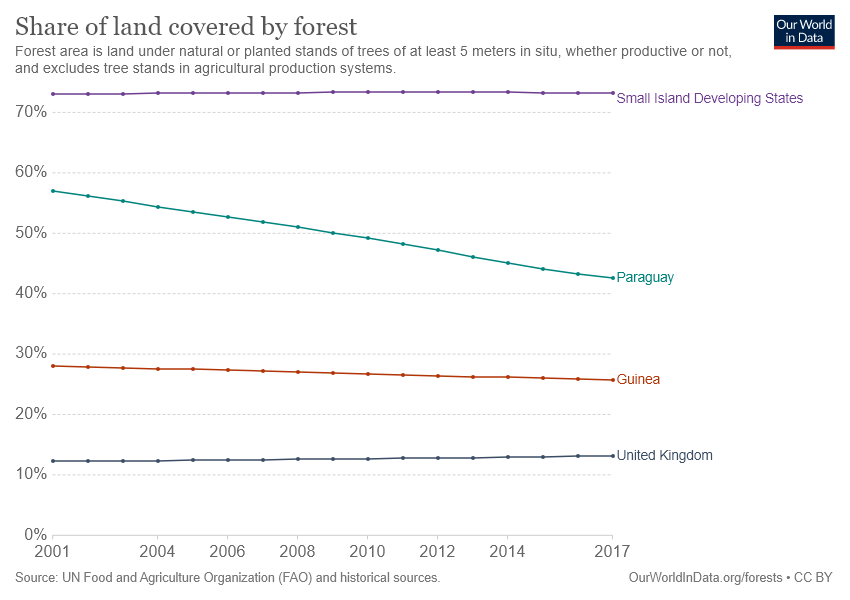Draw attention to some important aspects in this diagram. The share of land covered by forest in Paraguay is decreasing over the years, and this trend is continuing. For how many years has the share of land covered by forest in Paraguay been greater than 50%? The answer is 8 years. 